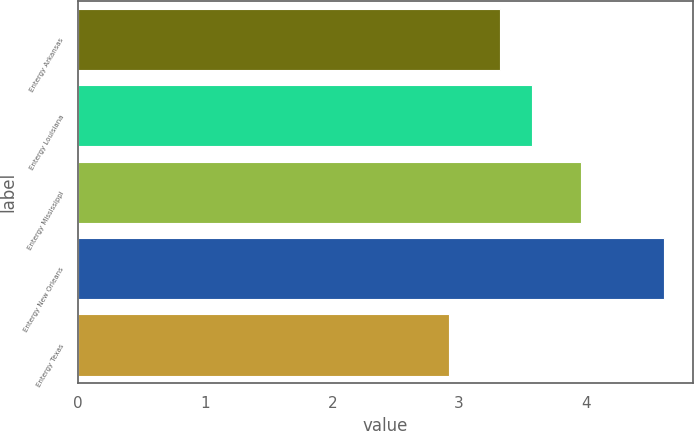Convert chart. <chart><loc_0><loc_0><loc_500><loc_500><bar_chart><fcel>Entergy Arkansas<fcel>Entergy Louisiana<fcel>Entergy Mississippi<fcel>Entergy New Orleans<fcel>Entergy Texas<nl><fcel>3.32<fcel>3.57<fcel>3.96<fcel>4.61<fcel>2.92<nl></chart> 